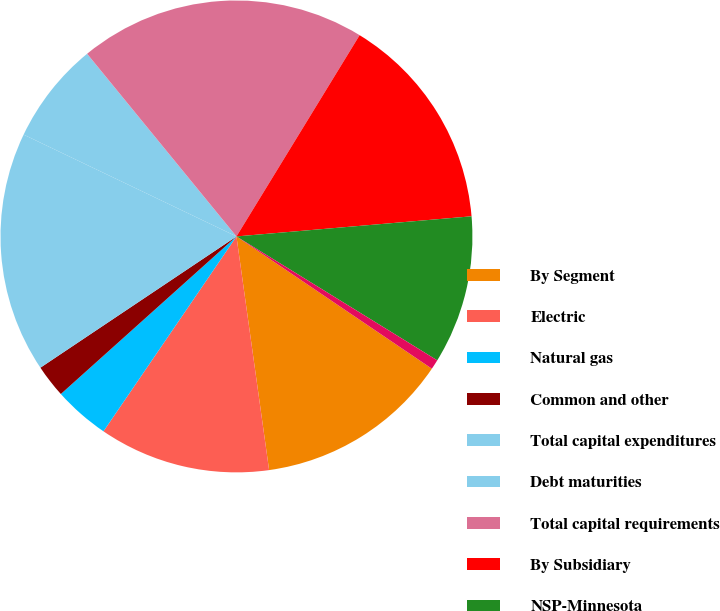Convert chart. <chart><loc_0><loc_0><loc_500><loc_500><pie_chart><fcel>By Segment<fcel>Electric<fcel>Natural gas<fcel>Common and other<fcel>Total capital expenditures<fcel>Debt maturities<fcel>Total capital requirements<fcel>By Subsidiary<fcel>NSP-Minnesota<fcel>NSP-Wisconsin<nl><fcel>13.32%<fcel>11.74%<fcel>3.83%<fcel>2.25%<fcel>16.49%<fcel>6.99%<fcel>19.65%<fcel>14.9%<fcel>10.16%<fcel>0.67%<nl></chart> 